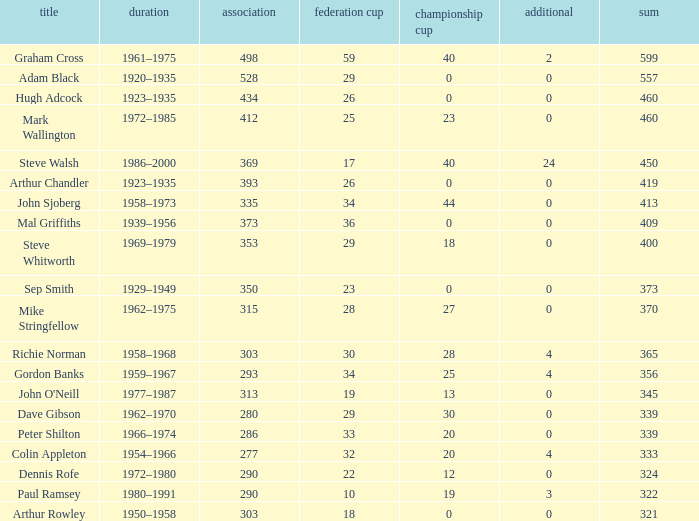What is the lowest number of League Cups a player with a 434 league has? 0.0. 